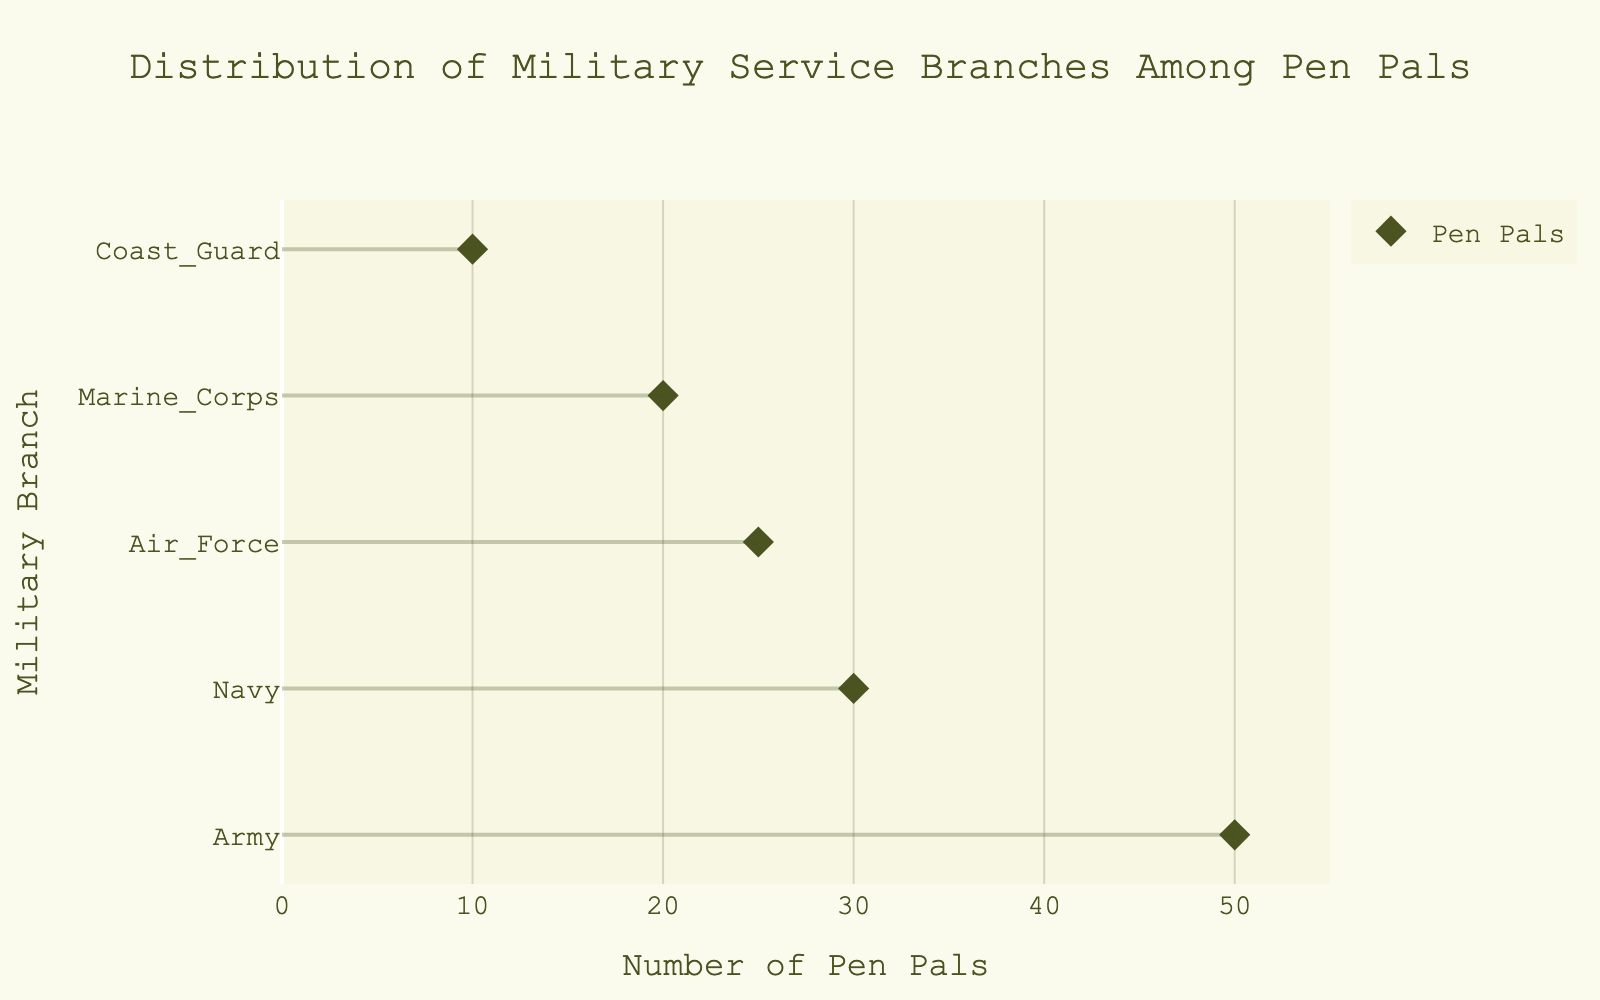What is the title of the plot? The title is typically located at the top of the plot and is designed to give an overview of the data being visualized. In this case, checking the provided title in the layout details confirms it.
Answer: Distribution of Military Service Branches Among Pen Pals Which military branch has the highest number of pen pals? By looking at the y-axis labels and the corresponding x-axis value representing the number of pen pals, the branch located at the highest x-axis value is identifiable.
Answer: Army How many pen pals are associated with the Marine Corps? Locate the Marine Corps on the y-axis and then see the corresponding point on the x-axis to determine the number of pen pals.
Answer: 20 What is the difference in the number of pen pals between the Army and the Coast Guard? Identify the number of pen pals for both Army (50) and Coast Guard (10). Subtract the Coast Guard's number from the Army's. 50 - 10 = 40.
Answer: 40 Which military branch has the least number of pen pals? Scan the plot to find the point with the lowest x-axis value, which signifies the smallest number of pen pals.
Answer: Coast Guard What is the total number of pen pals across all branches? Add up the number of pen pals in each branch: 50 (Army) + 30 (Navy) + 25 (Air Force) + 20 (Marine Corps) + 10 (Coast Guard) = 135.
Answer: 135 Which branches have fewer pen pals than the Navy? Identify the number of pen pals for the Navy (30) and compare it with each branch's number. Both the Air Force, Marine Corps, and Coast Guard have fewer: 25, 20, and 10, respectively.
Answer: Air Force, Marine Corps, Coast Guard How many branches have more than 20 pen pals? Determine the number of pen pals for each branch and count those with numbers exceeding 20. Army (50), Navy (30), and Air Force (25) meet this criterion.
Answer: 3 What is the average number of pen pals per branch? Calculate the total number of pen pals (135) and divide it by the number of branches (5). 135 / 5 = 27.
Answer: 27 What visual marker symbol is used for representing the branches? By observing the plot's dots, the shape of symbols used can be identified. They are described as part of the plot configuration.
Answer: Diamond 